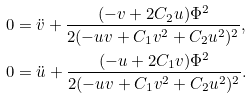Convert formula to latex. <formula><loc_0><loc_0><loc_500><loc_500>0 & = { \ddot { v } } + \frac { ( - v + 2 C _ { 2 } u ) \Phi ^ { 2 } } { 2 ( - u v + C _ { 1 } v ^ { 2 } + C _ { 2 } u ^ { 2 } ) ^ { 2 } } , \\ 0 & = { \ddot { u } } + \frac { ( - u + 2 C _ { 1 } v ) \Phi ^ { 2 } } { 2 ( - u v + C _ { 1 } v ^ { 2 } + C _ { 2 } u ^ { 2 } ) ^ { 2 } } .</formula> 